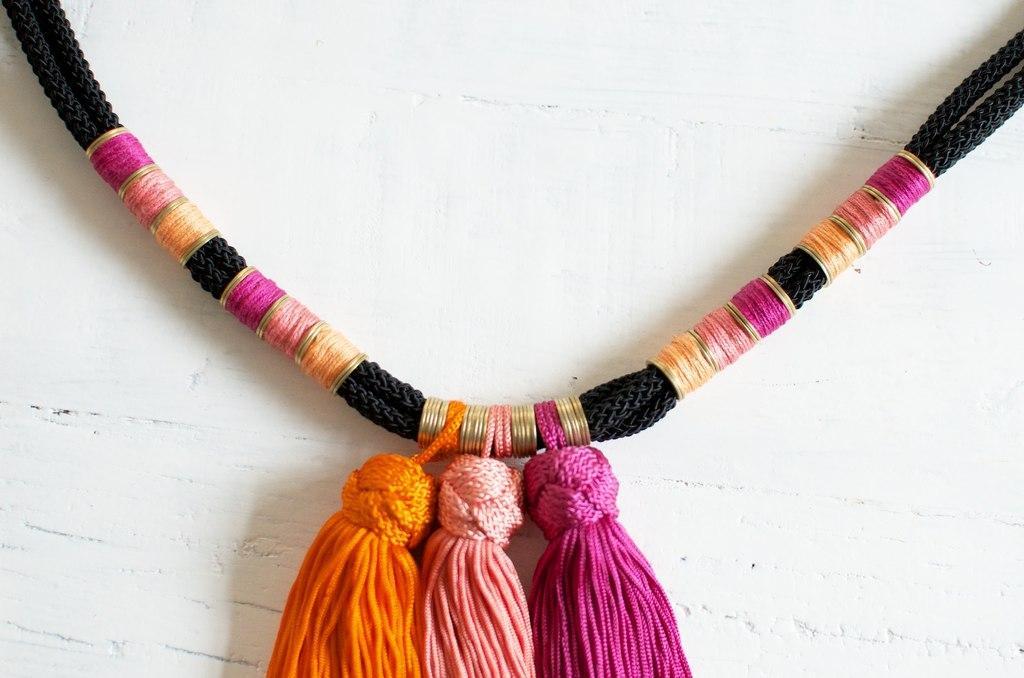In one or two sentences, can you explain what this image depicts? In this image I can see a black thread necklace. It has woolen hangings. There is a white background. 